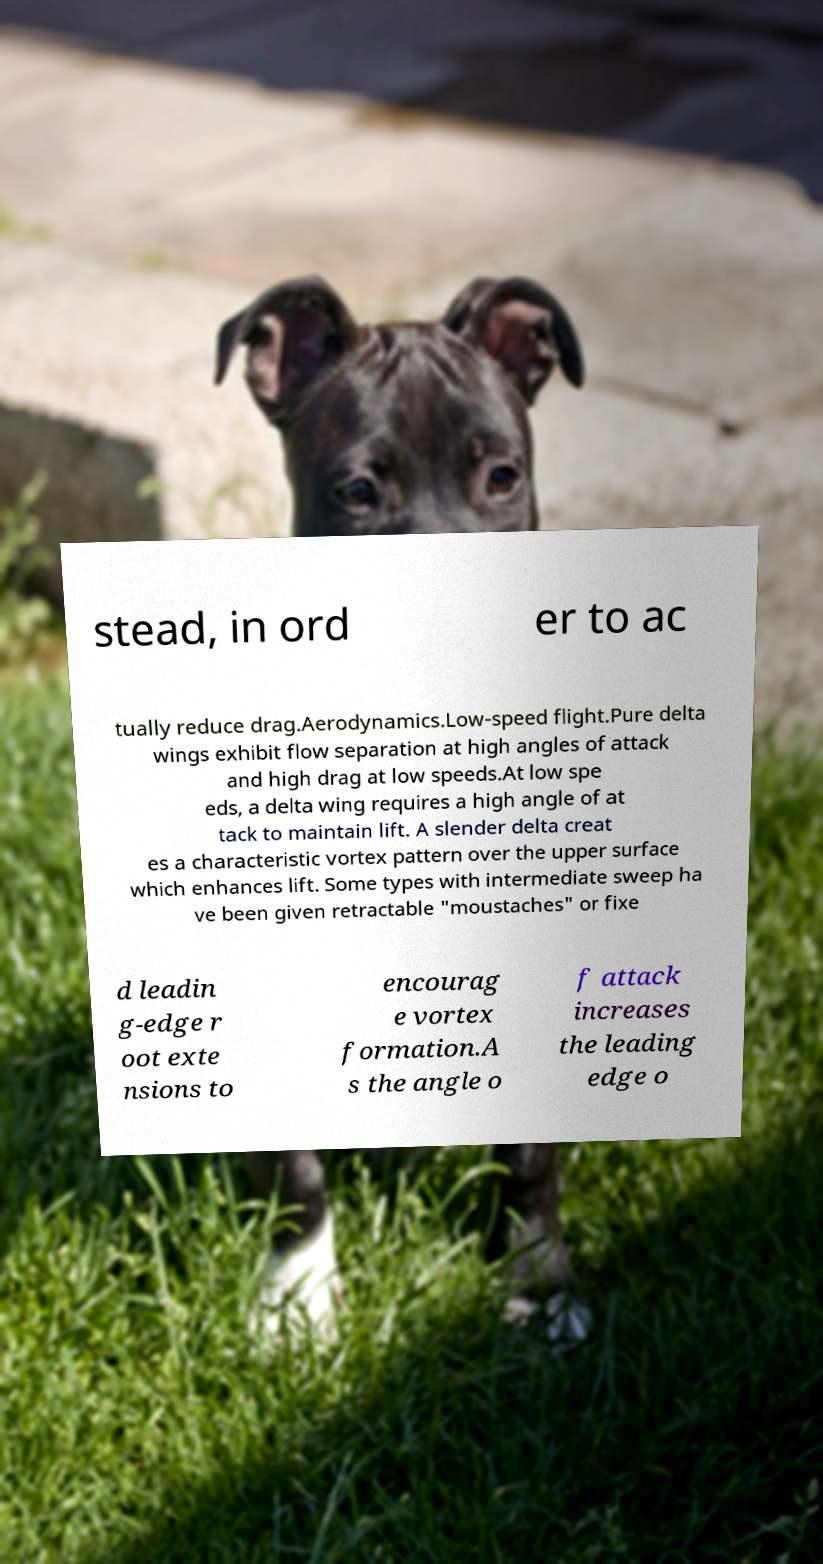Can you accurately transcribe the text from the provided image for me? stead, in ord er to ac tually reduce drag.Aerodynamics.Low-speed flight.Pure delta wings exhibit flow separation at high angles of attack and high drag at low speeds.At low spe eds, a delta wing requires a high angle of at tack to maintain lift. A slender delta creat es a characteristic vortex pattern over the upper surface which enhances lift. Some types with intermediate sweep ha ve been given retractable "moustaches" or fixe d leadin g-edge r oot exte nsions to encourag e vortex formation.A s the angle o f attack increases the leading edge o 